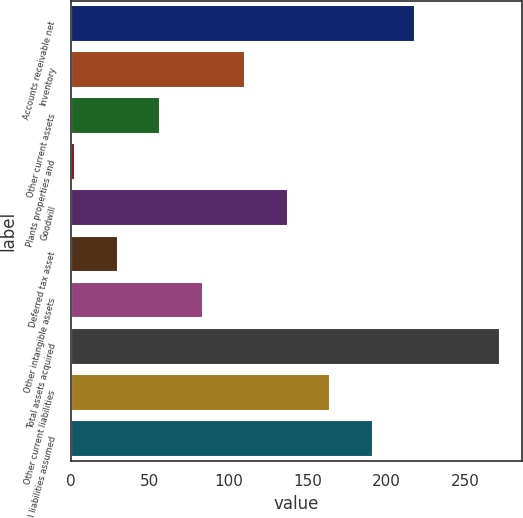Convert chart to OTSL. <chart><loc_0><loc_0><loc_500><loc_500><bar_chart><fcel>Accounts receivable net<fcel>Inventory<fcel>Other current assets<fcel>Plants properties and<fcel>Goodwill<fcel>Deferred tax asset<fcel>Other intangible assets<fcel>Total assets acquired<fcel>Other current liabilities<fcel>Total liabilities assumed<nl><fcel>218.2<fcel>110.6<fcel>56.8<fcel>3<fcel>137.5<fcel>29.9<fcel>83.7<fcel>272<fcel>164.4<fcel>191.3<nl></chart> 